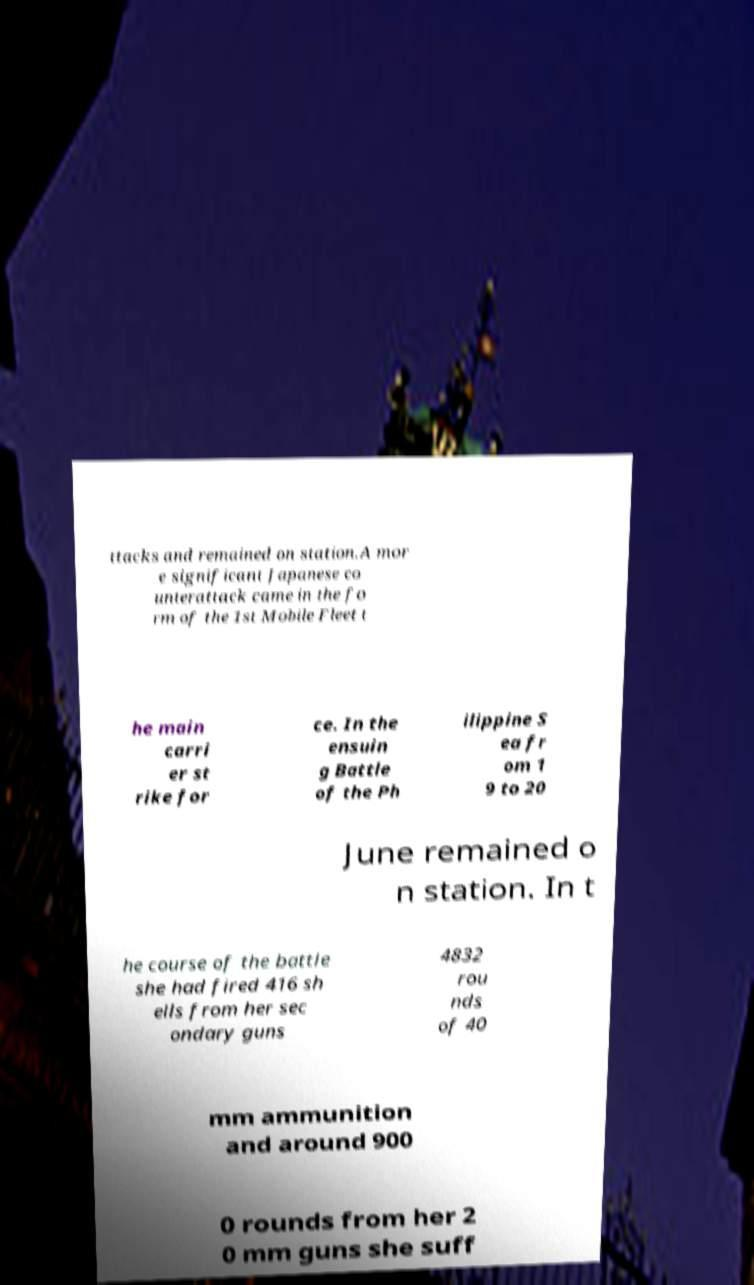I need the written content from this picture converted into text. Can you do that? ttacks and remained on station.A mor e significant Japanese co unterattack came in the fo rm of the 1st Mobile Fleet t he main carri er st rike for ce. In the ensuin g Battle of the Ph ilippine S ea fr om 1 9 to 20 June remained o n station. In t he course of the battle she had fired 416 sh ells from her sec ondary guns 4832 rou nds of 40 mm ammunition and around 900 0 rounds from her 2 0 mm guns she suff 